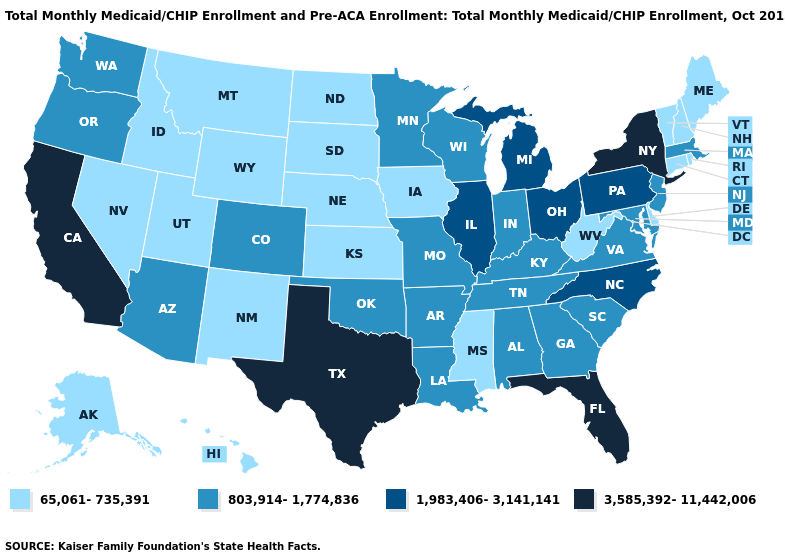Which states have the lowest value in the South?
Be succinct. Delaware, Mississippi, West Virginia. What is the value of Oregon?
Write a very short answer. 803,914-1,774,836. What is the highest value in states that border Nevada?
Give a very brief answer. 3,585,392-11,442,006. Does Hawaii have a lower value than Montana?
Give a very brief answer. No. Does Kansas have the lowest value in the USA?
Keep it brief. Yes. What is the lowest value in the USA?
Answer briefly. 65,061-735,391. What is the value of New Jersey?
Short answer required. 803,914-1,774,836. Name the states that have a value in the range 65,061-735,391?
Be succinct. Alaska, Connecticut, Delaware, Hawaii, Idaho, Iowa, Kansas, Maine, Mississippi, Montana, Nebraska, Nevada, New Hampshire, New Mexico, North Dakota, Rhode Island, South Dakota, Utah, Vermont, West Virginia, Wyoming. What is the highest value in the USA?
Concise answer only. 3,585,392-11,442,006. Name the states that have a value in the range 3,585,392-11,442,006?
Keep it brief. California, Florida, New York, Texas. Which states have the lowest value in the South?
Answer briefly. Delaware, Mississippi, West Virginia. Name the states that have a value in the range 803,914-1,774,836?
Write a very short answer. Alabama, Arizona, Arkansas, Colorado, Georgia, Indiana, Kentucky, Louisiana, Maryland, Massachusetts, Minnesota, Missouri, New Jersey, Oklahoma, Oregon, South Carolina, Tennessee, Virginia, Washington, Wisconsin. Among the states that border Ohio , which have the lowest value?
Be succinct. West Virginia. Does Iowa have the same value as Ohio?
Answer briefly. No. Which states hav the highest value in the MidWest?
Be succinct. Illinois, Michigan, Ohio. 